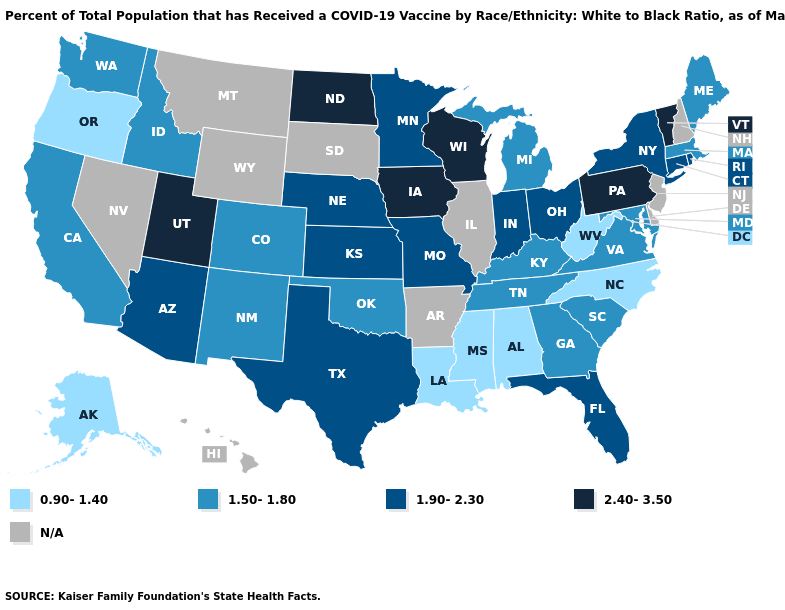Name the states that have a value in the range 1.50-1.80?
Concise answer only. California, Colorado, Georgia, Idaho, Kentucky, Maine, Maryland, Massachusetts, Michigan, New Mexico, Oklahoma, South Carolina, Tennessee, Virginia, Washington. Is the legend a continuous bar?
Short answer required. No. Does Alaska have the highest value in the USA?
Be succinct. No. Does the first symbol in the legend represent the smallest category?
Give a very brief answer. Yes. Among the states that border North Carolina , which have the highest value?
Write a very short answer. Georgia, South Carolina, Tennessee, Virginia. How many symbols are there in the legend?
Short answer required. 5. What is the value of New York?
Answer briefly. 1.90-2.30. Which states have the lowest value in the West?
Be succinct. Alaska, Oregon. What is the value of Wyoming?
Short answer required. N/A. What is the lowest value in states that border Texas?
Write a very short answer. 0.90-1.40. Does Maine have the lowest value in the USA?
Answer briefly. No. Does South Carolina have the lowest value in the South?
Answer briefly. No. Does the first symbol in the legend represent the smallest category?
Be succinct. Yes. What is the value of Mississippi?
Give a very brief answer. 0.90-1.40. Does Alaska have the highest value in the USA?
Give a very brief answer. No. 